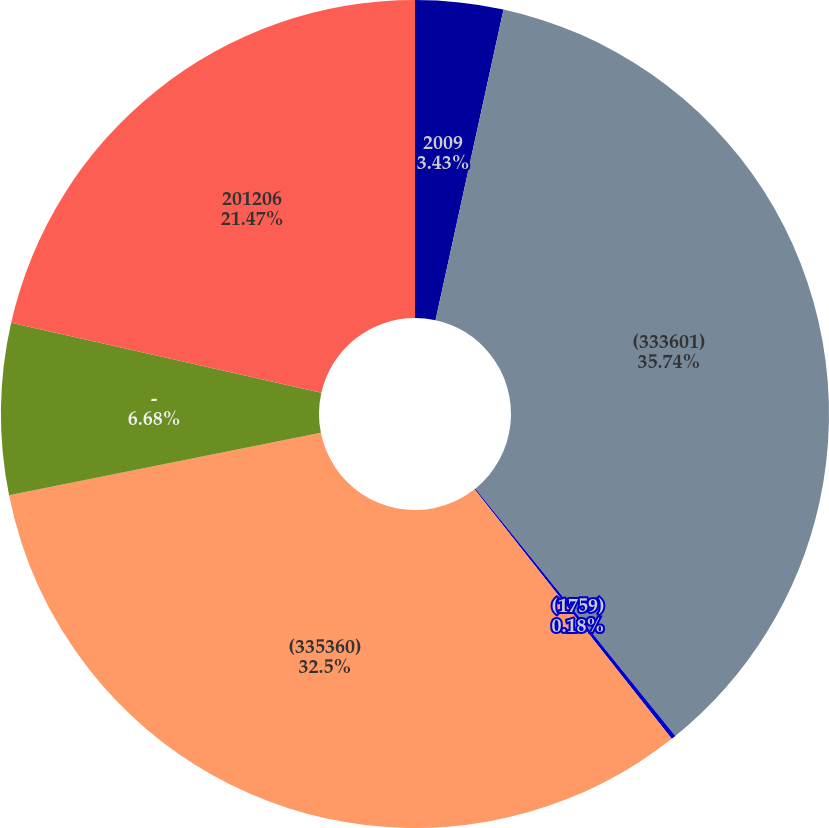<chart> <loc_0><loc_0><loc_500><loc_500><pie_chart><fcel>2009<fcel>(333601)<fcel>(1759)<fcel>(335360)<fcel>-<fcel>201206<nl><fcel>3.43%<fcel>35.75%<fcel>0.18%<fcel>32.5%<fcel>6.68%<fcel>21.47%<nl></chart> 